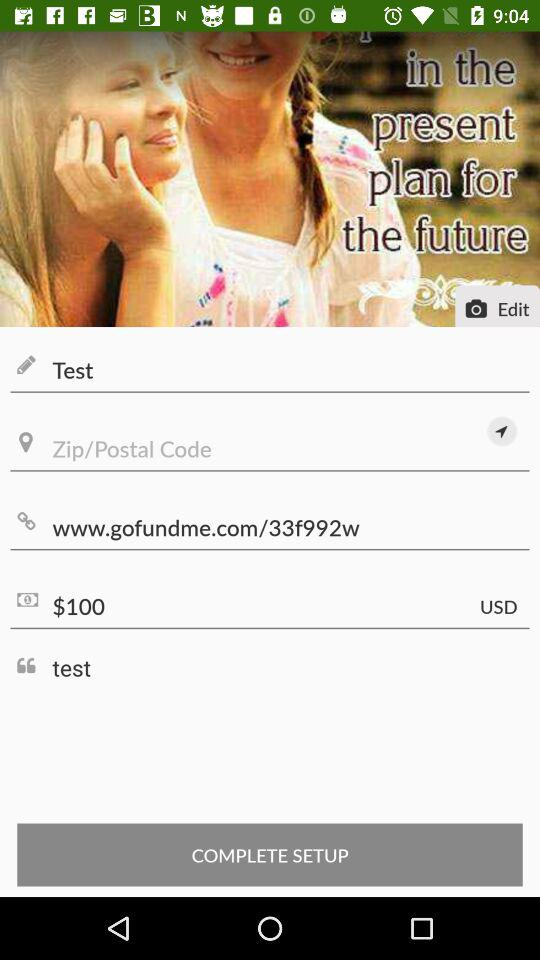What is the website? The website is www.gofundme.com/33f992w. 